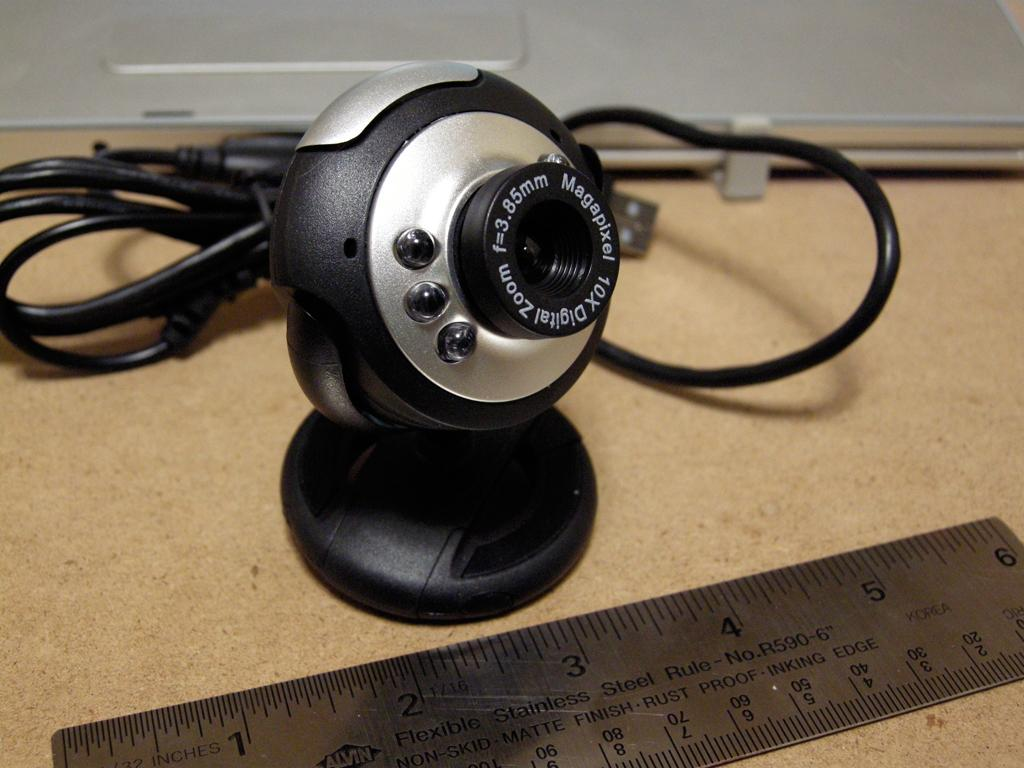<image>
Create a compact narrative representing the image presented. Webcam which says MAGAPIXEL on it is being measured. 